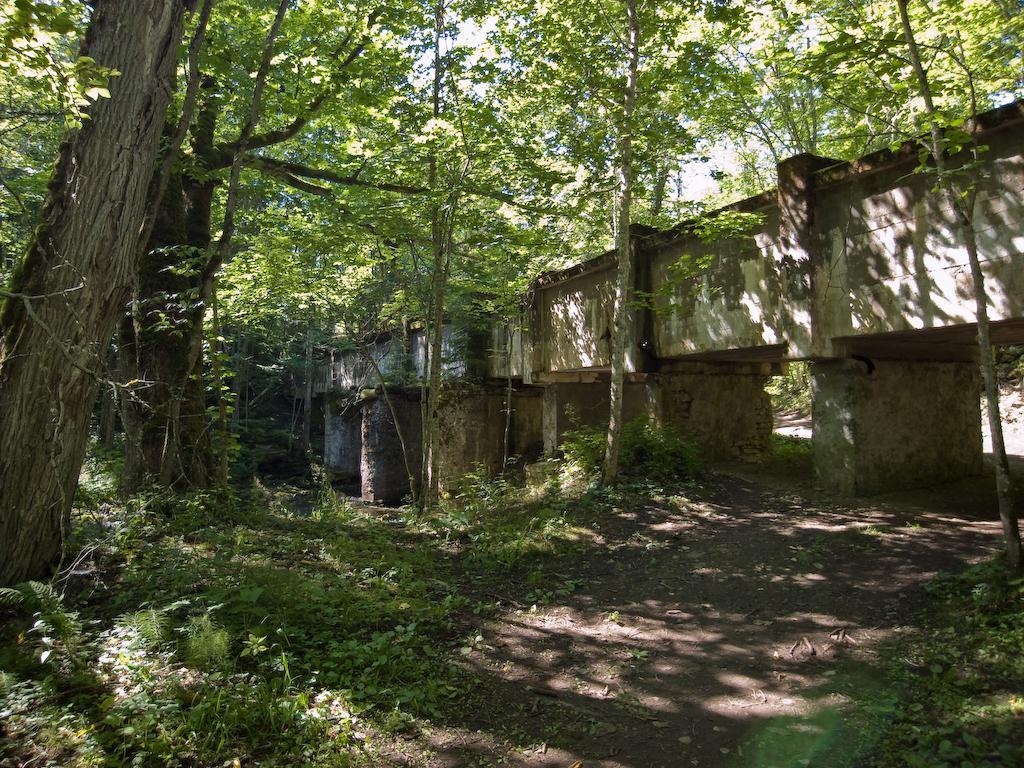Can you describe this image briefly? In this picture we can see some plants at the bottom, on the right side it looks like a bridge, in the background there are some trees, we can see the sky at the top of the picture. 